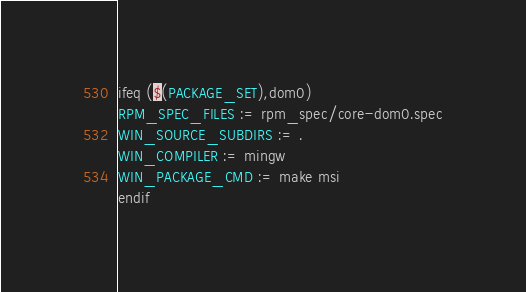<code> <loc_0><loc_0><loc_500><loc_500><_Ruby_>ifeq ($(PACKAGE_SET),dom0)
RPM_SPEC_FILES := rpm_spec/core-dom0.spec
WIN_SOURCE_SUBDIRS := .
WIN_COMPILER := mingw
WIN_PACKAGE_CMD := make msi
endif</code> 